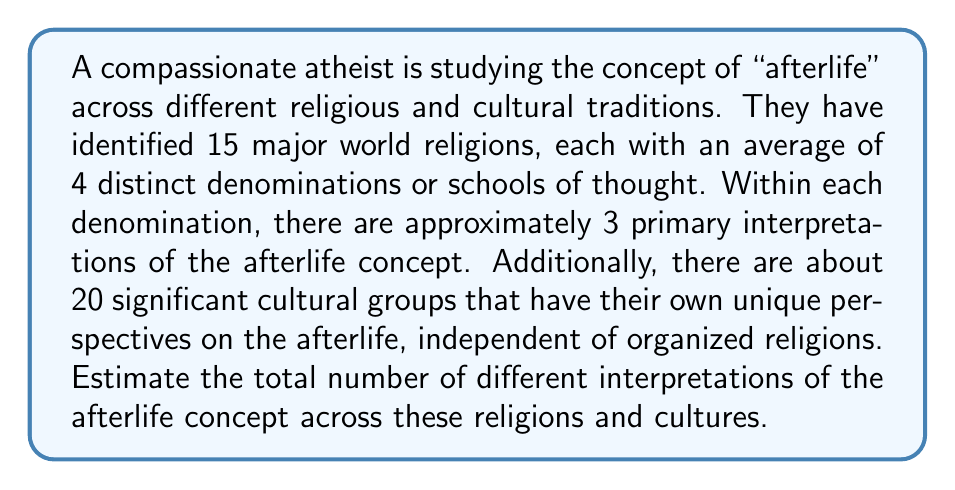Can you solve this math problem? To solve this problem, we'll break it down into steps:

1. Calculate the number of interpretations within organized religions:
   - Number of major world religions: 15
   - Average number of denominations per religion: 4
   - Number of primary interpretations per denomination: 3
   
   Total interpretations in organized religions:
   $$ 15 \times 4 \times 3 = 180 $$

2. Add the number of cultural interpretations:
   - Number of significant cultural groups with unique perspectives: 20

3. Sum up the total number of interpretations:
   $$ \text{Total interpretations} = \text{Religious interpretations} + \text{Cultural interpretations} $$
   $$ \text{Total interpretations} = 180 + 20 = 200 $$

This estimate assumes that each interpretation is distinct and does not account for potential overlaps or similarities between different religious and cultural views. In reality, there might be some shared elements across different interpretations, but for the purpose of this estimation, we treat each as unique.
Answer: The estimated number of different interpretations of the afterlife concept across multiple religions and cultures is approximately 200. 